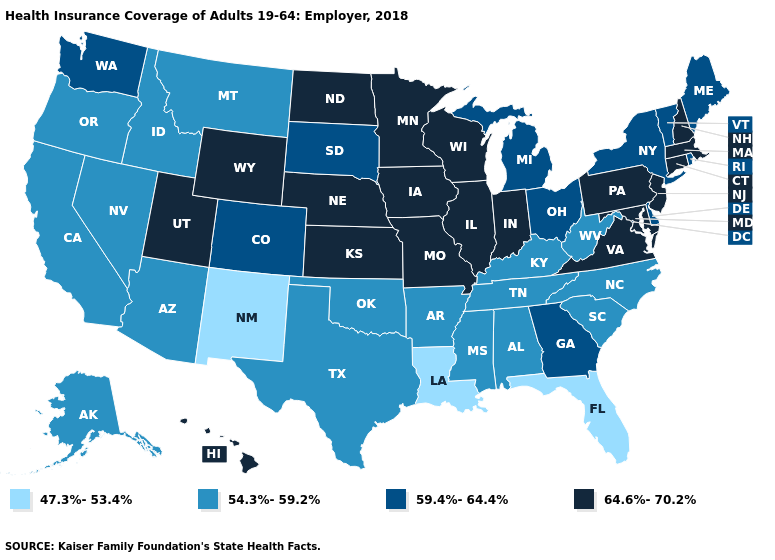Name the states that have a value in the range 59.4%-64.4%?
Write a very short answer. Colorado, Delaware, Georgia, Maine, Michigan, New York, Ohio, Rhode Island, South Dakota, Vermont, Washington. What is the lowest value in states that border New York?
Keep it brief. 59.4%-64.4%. What is the value of Michigan?
Concise answer only. 59.4%-64.4%. Name the states that have a value in the range 54.3%-59.2%?
Keep it brief. Alabama, Alaska, Arizona, Arkansas, California, Idaho, Kentucky, Mississippi, Montana, Nevada, North Carolina, Oklahoma, Oregon, South Carolina, Tennessee, Texas, West Virginia. Name the states that have a value in the range 47.3%-53.4%?
Be succinct. Florida, Louisiana, New Mexico. Which states hav the highest value in the MidWest?
Be succinct. Illinois, Indiana, Iowa, Kansas, Minnesota, Missouri, Nebraska, North Dakota, Wisconsin. Does Indiana have the lowest value in the MidWest?
Short answer required. No. Name the states that have a value in the range 64.6%-70.2%?
Short answer required. Connecticut, Hawaii, Illinois, Indiana, Iowa, Kansas, Maryland, Massachusetts, Minnesota, Missouri, Nebraska, New Hampshire, New Jersey, North Dakota, Pennsylvania, Utah, Virginia, Wisconsin, Wyoming. Which states hav the highest value in the Northeast?
Be succinct. Connecticut, Massachusetts, New Hampshire, New Jersey, Pennsylvania. Name the states that have a value in the range 47.3%-53.4%?
Concise answer only. Florida, Louisiana, New Mexico. Name the states that have a value in the range 64.6%-70.2%?
Give a very brief answer. Connecticut, Hawaii, Illinois, Indiana, Iowa, Kansas, Maryland, Massachusetts, Minnesota, Missouri, Nebraska, New Hampshire, New Jersey, North Dakota, Pennsylvania, Utah, Virginia, Wisconsin, Wyoming. What is the lowest value in states that border North Dakota?
Short answer required. 54.3%-59.2%. What is the value of New Jersey?
Quick response, please. 64.6%-70.2%. Does Colorado have a higher value than North Dakota?
Write a very short answer. No. Which states have the lowest value in the USA?
Write a very short answer. Florida, Louisiana, New Mexico. 